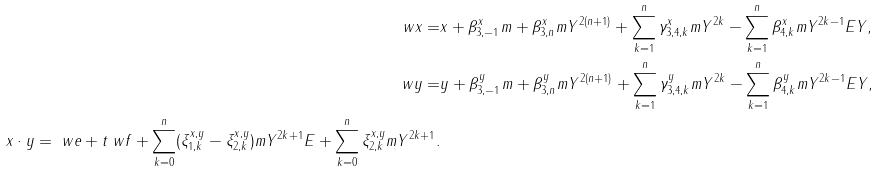Convert formula to latex. <formula><loc_0><loc_0><loc_500><loc_500>\ w x = & x + \beta _ { 3 , - 1 } ^ { x } m + \beta _ { 3 , n } ^ { x } m Y ^ { 2 ( n + 1 ) } + \sum _ { k = 1 } ^ { n } \gamma _ { 3 , 4 , k } ^ { x } m Y ^ { 2 k } - \sum _ { k = 1 } ^ { n } \beta _ { 4 , k } ^ { x } m Y ^ { 2 k - 1 } E Y , \\ \ w y = & y + \beta _ { 3 , - 1 } ^ { y } m + \beta _ { 3 , n } ^ { y } m Y ^ { 2 ( n + 1 ) } + \sum _ { k = 1 } ^ { n } \gamma _ { 3 , 4 , k } ^ { y } m Y ^ { 2 k } - \sum _ { k = 1 } ^ { n } \beta _ { 4 , k } ^ { y } m Y ^ { 2 k - 1 } E Y , \\ x \cdot y = \ w e + t \ w f + \sum _ { k = 0 } ^ { n } ( \xi _ { 1 , k } ^ { x , y } - \xi _ { 2 , k } ^ { x , y } ) m Y ^ { 2 k + 1 } E + \sum _ { k = 0 } ^ { n } \xi _ { 2 , k } ^ { x , y } m Y ^ { 2 k + 1 } .</formula> 